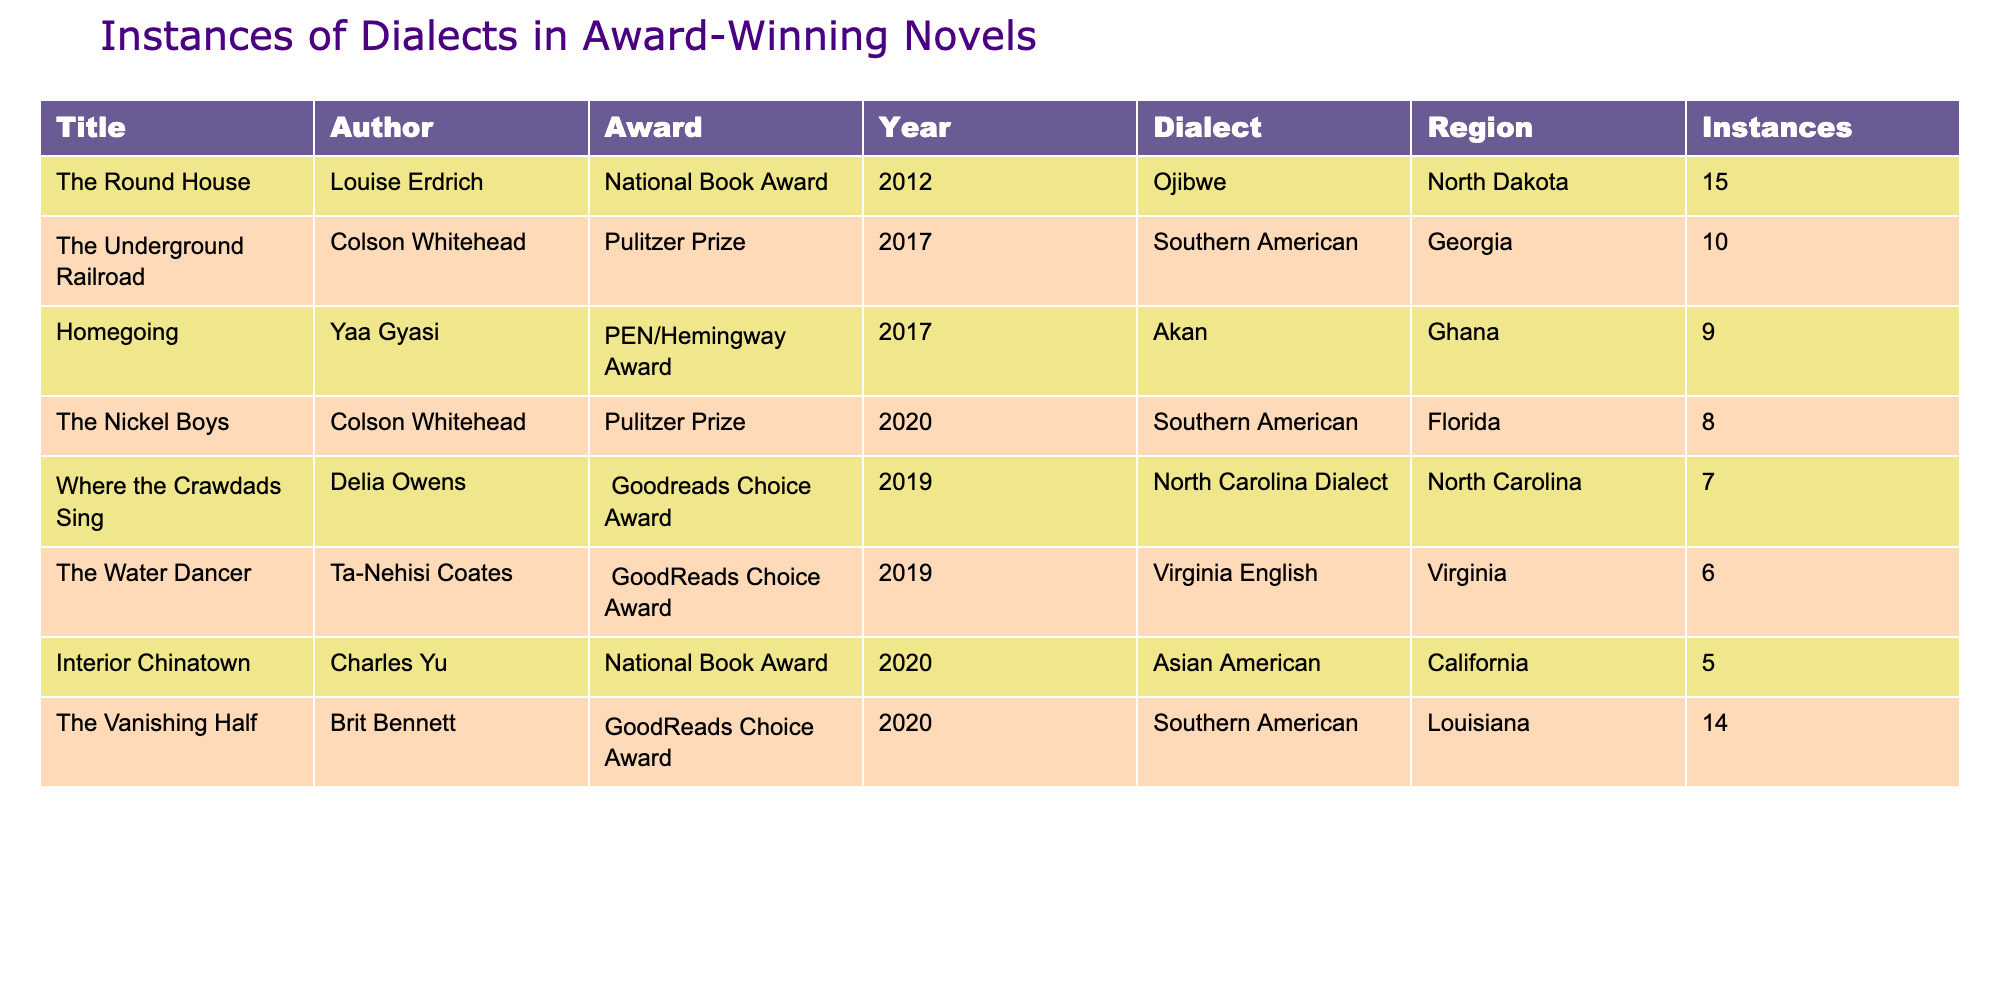What dialect is used in "The Round House"? The table lists the title "The Round House" alongside its corresponding dialect, which is Ojibwe.
Answer: Ojibwe Which novel has the highest number of dialect instances? By examining the instances listed, "The Round House" has 15 instances, which is the highest compared to other novels in the table.
Answer: The Round House Is there any novel that incorporates the African Akan dialect? The table has "Homegoing" by Yaa Gyasi listed, which indicates that it does incorporate the Akan dialect.
Answer: Yes What is the total number of instances of Southern American dialect across all novels? The Southern American dialect appears in three novels: "The Underground Railroad" (10), "The Nickel Boys" (8), and "The Vanishing Half" (14). Summing these gives 10 + 8 + 14 = 32.
Answer: 32 How many novels incorporate a dialect from the State of Virginia? Only one novel features a dialect from Virginia, which is "The Water Dancer."
Answer: 1 Which region has the least representation in this table? By reviewing the regions in the table, California with "Interior Chinatown" (5 instances) has the least representation compared to others listed; thus, it can be deduced that California is the least represented region.
Answer: California Are there any novels that feature more than 10 instances of dialect? Analyzing the instances, the novels "The Round House" (15) and "The Vanishing Half" (14) both feature more than 10 instances of dialect.
Answer: Yes What is the average number of instances for all the novels listed? The total count of instances is 15 + 10 + 9 + 8 + 7 + 6 + 5 + 14 = 74. There are 8 novels, so the average is 74 / 8 = 9.25.
Answer: 9.25 How many unique dialects are mentioned in the table? By reviewing the dialects listed for each novel, there are 7 unique dialects: Ojibwe, Southern American, Akan, North Carolina Dialect, Virginia English, Asian American, and Southern American. Since Southern American appears multiple times, it is only counted once.
Answer: 7 